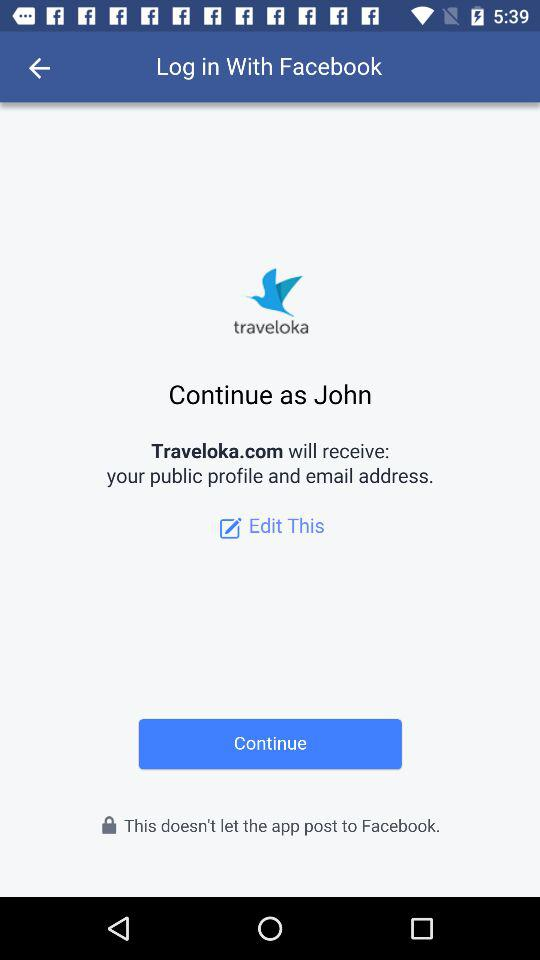What application will receive a public profile and email address? The application name is "Traveloka.com". 